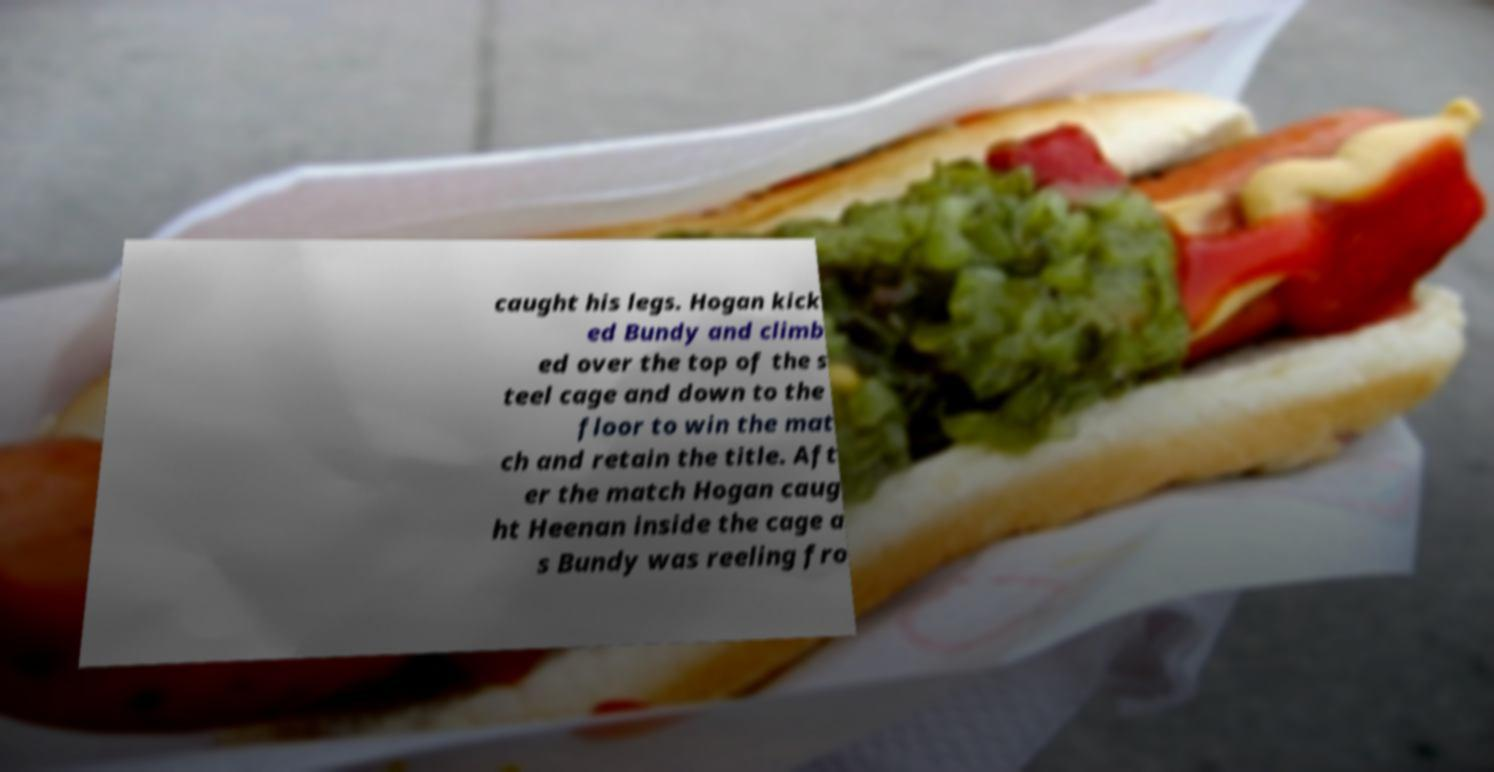There's text embedded in this image that I need extracted. Can you transcribe it verbatim? caught his legs. Hogan kick ed Bundy and climb ed over the top of the s teel cage and down to the floor to win the mat ch and retain the title. Aft er the match Hogan caug ht Heenan inside the cage a s Bundy was reeling fro 